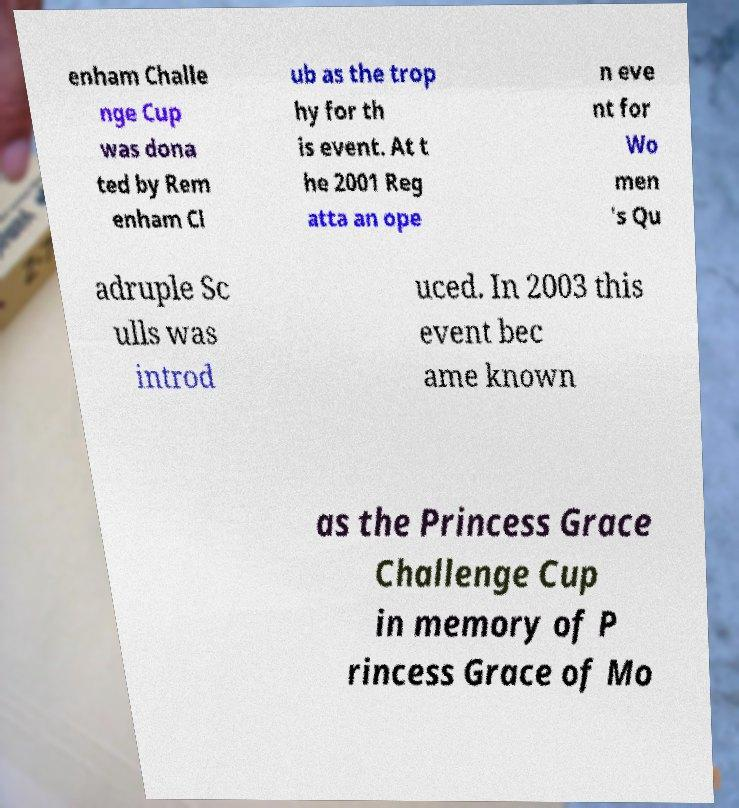I need the written content from this picture converted into text. Can you do that? enham Challe nge Cup was dona ted by Rem enham Cl ub as the trop hy for th is event. At t he 2001 Reg atta an ope n eve nt for Wo men 's Qu adruple Sc ulls was introd uced. In 2003 this event bec ame known as the Princess Grace Challenge Cup in memory of P rincess Grace of Mo 